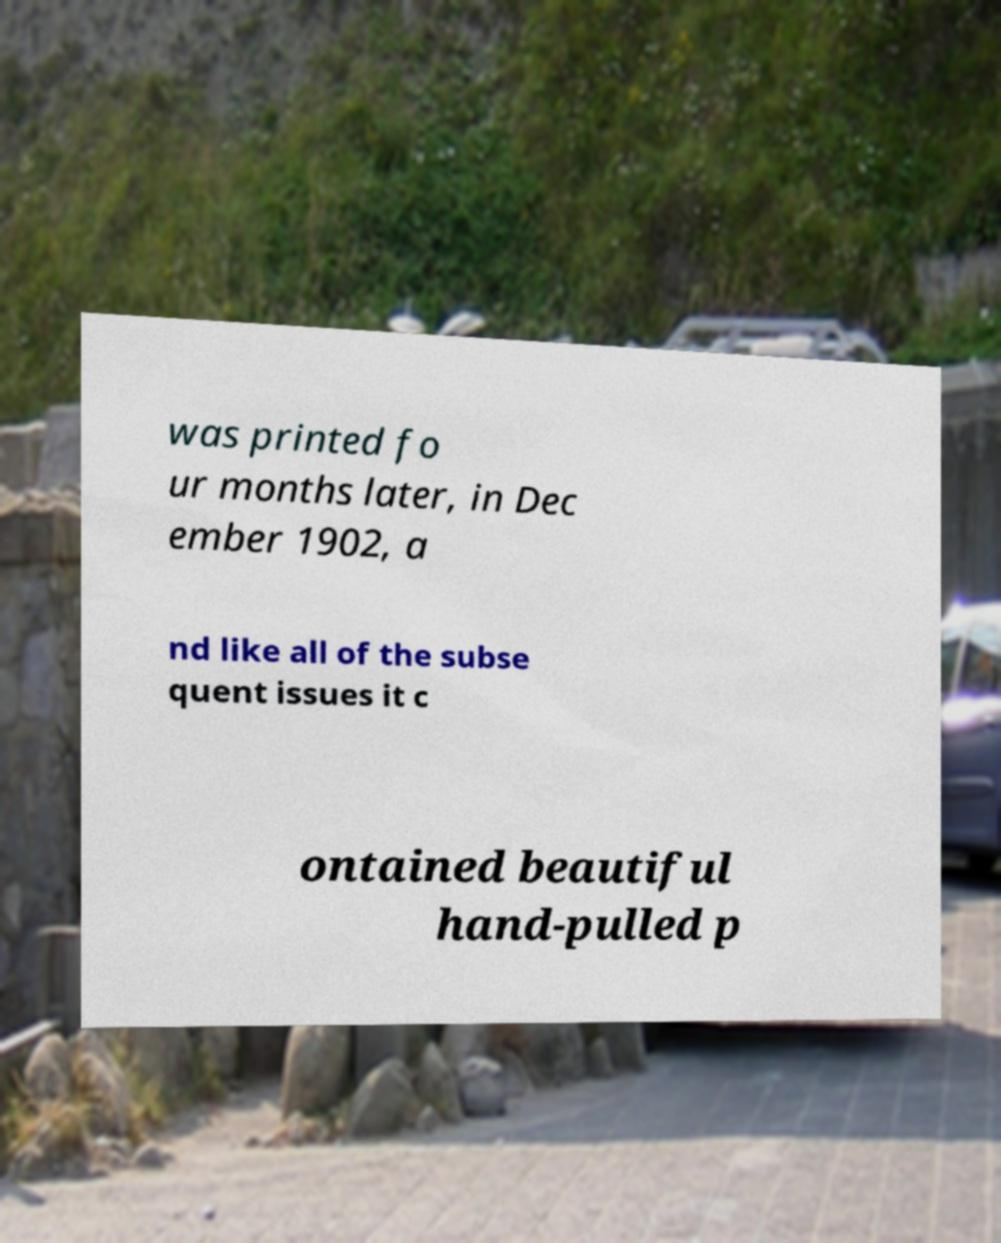What messages or text are displayed in this image? I need them in a readable, typed format. was printed fo ur months later, in Dec ember 1902, a nd like all of the subse quent issues it c ontained beautiful hand-pulled p 